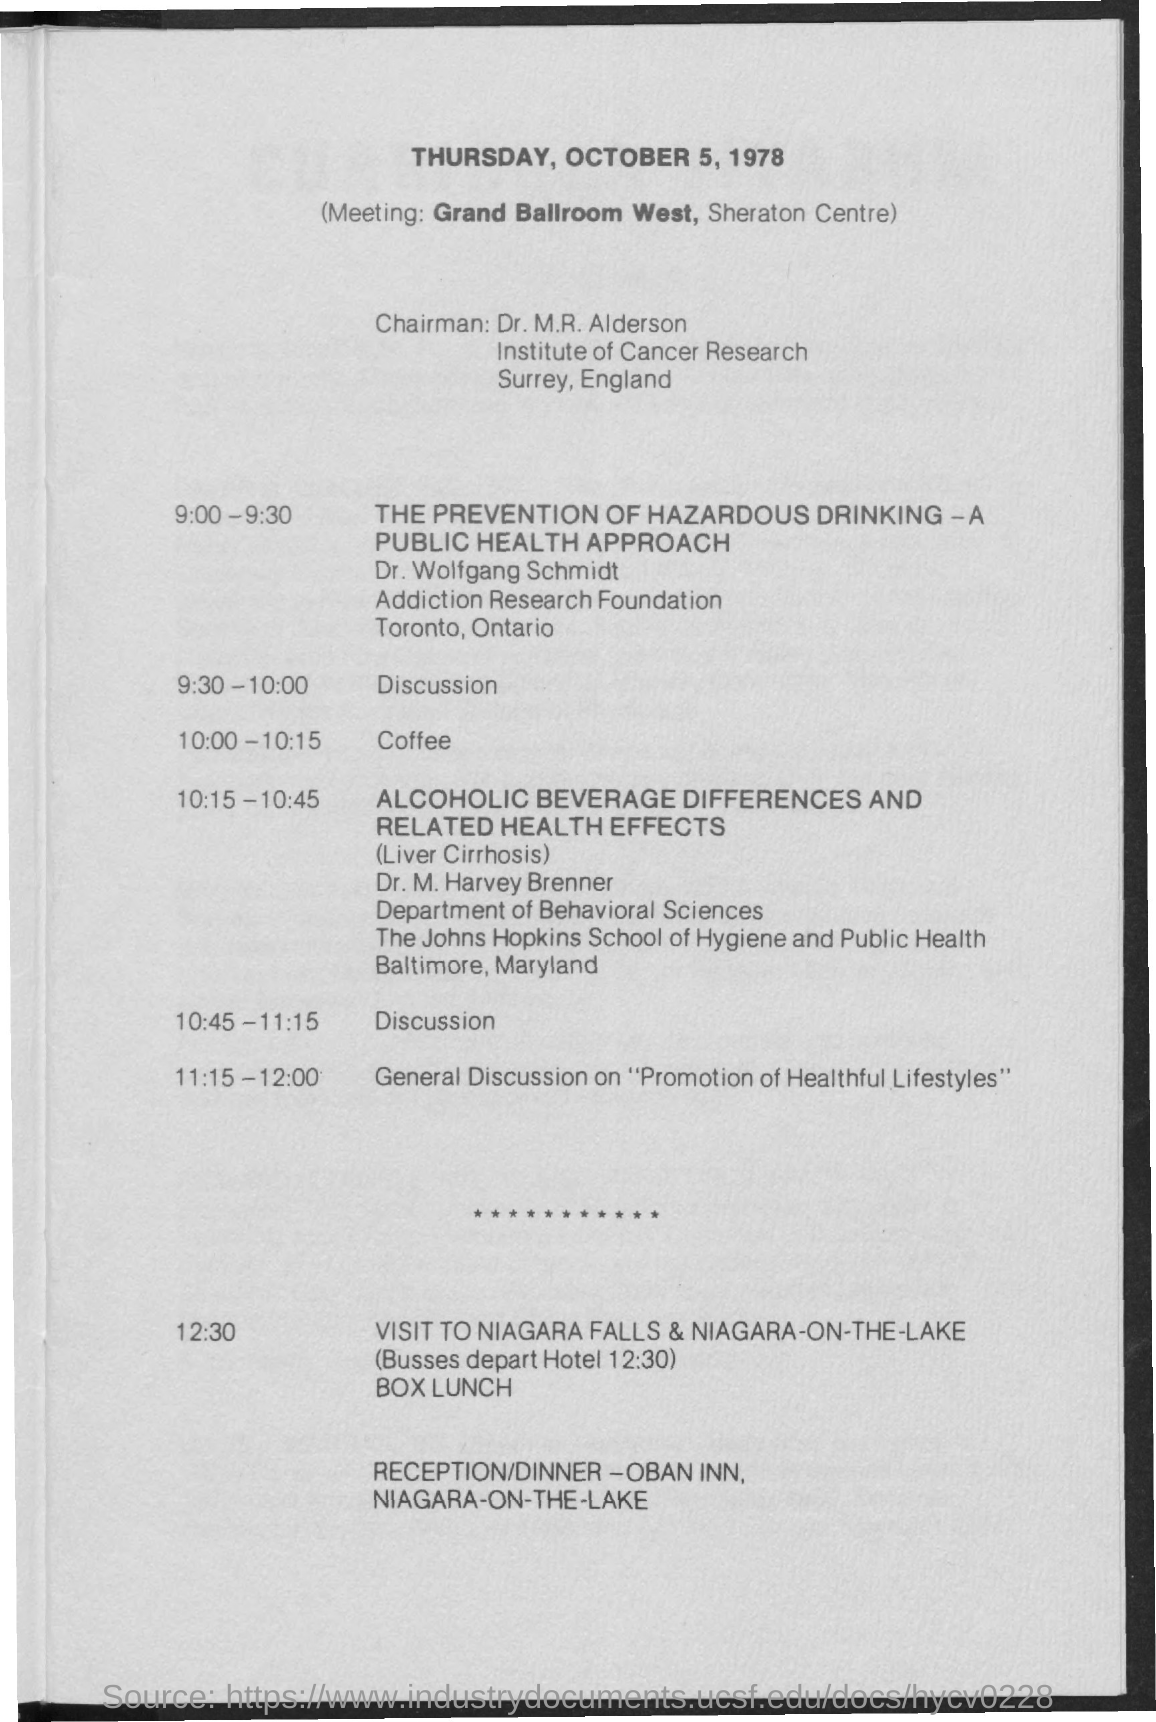List a handful of essential elements in this visual. Dr. M.R. Alderson is the Chairman. The meeting will take place in the Grand Ballroom West at the Sheraton Centre. The meeting will take place on Thursday, October 5, 1978. The coffee will be served between 10:00 and 10:15. The general discussion on "Promotion of Healthful Lifestyles" is scheduled to take place from 11:15-12:00. 